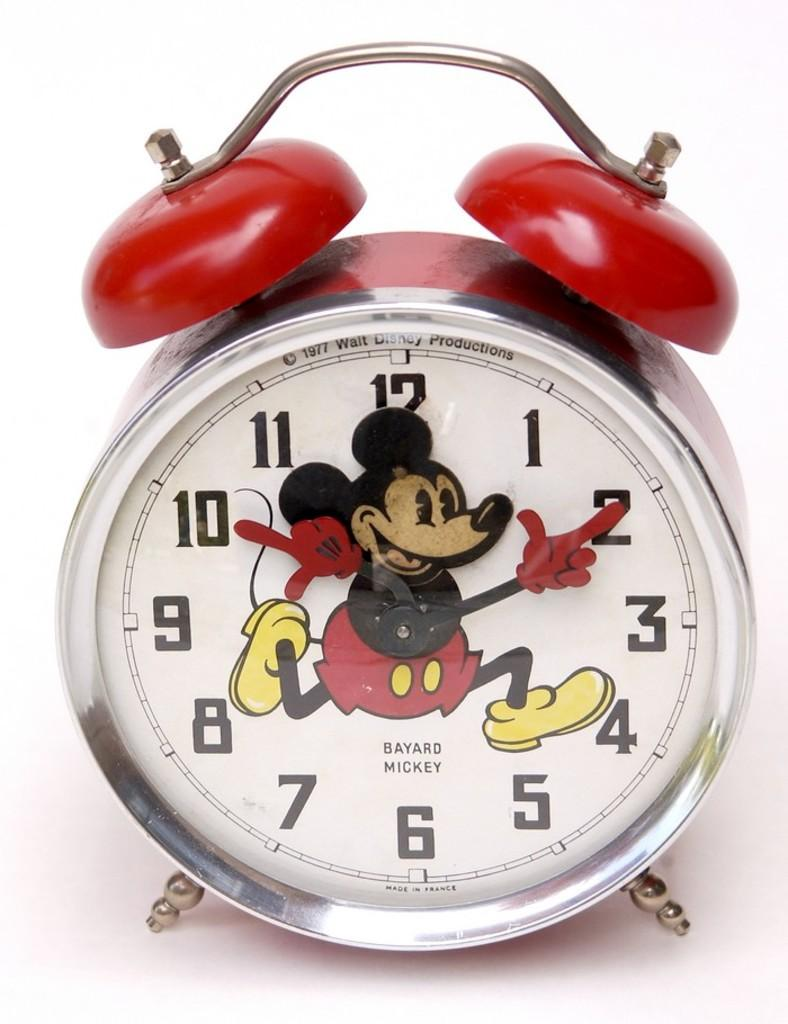Provide a one-sentence caption for the provided image. A mickey mouse clock displaying a copyright from 1977. 